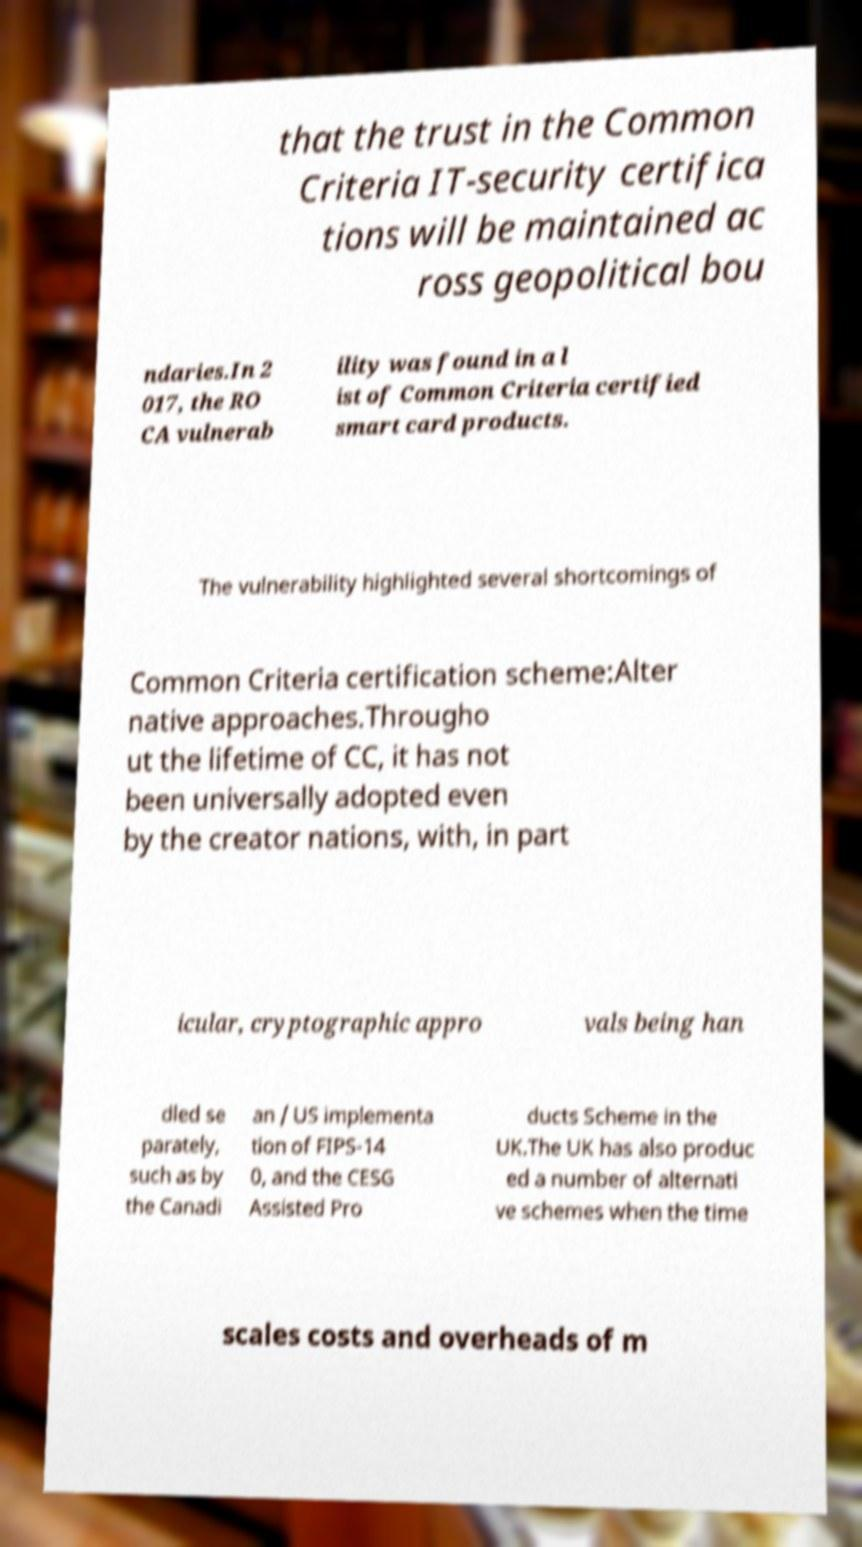Could you extract and type out the text from this image? that the trust in the Common Criteria IT-security certifica tions will be maintained ac ross geopolitical bou ndaries.In 2 017, the RO CA vulnerab ility was found in a l ist of Common Criteria certified smart card products. The vulnerability highlighted several shortcomings of Common Criteria certification scheme:Alter native approaches.Througho ut the lifetime of CC, it has not been universally adopted even by the creator nations, with, in part icular, cryptographic appro vals being han dled se parately, such as by the Canadi an / US implementa tion of FIPS-14 0, and the CESG Assisted Pro ducts Scheme in the UK.The UK has also produc ed a number of alternati ve schemes when the time scales costs and overheads of m 